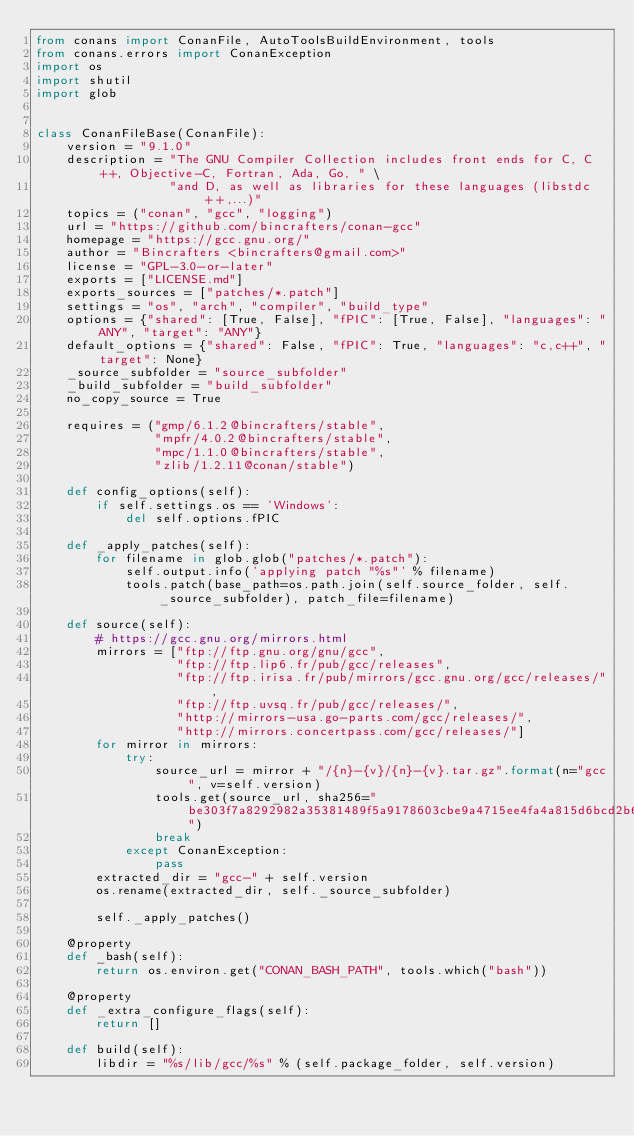<code> <loc_0><loc_0><loc_500><loc_500><_Python_>from conans import ConanFile, AutoToolsBuildEnvironment, tools
from conans.errors import ConanException
import os
import shutil
import glob


class ConanFileBase(ConanFile):
    version = "9.1.0"
    description = "The GNU Compiler Collection includes front ends for C, C++, Objective-C, Fortran, Ada, Go, " \
                  "and D, as well as libraries for these languages (libstdc++,...)"
    topics = ("conan", "gcc", "logging")
    url = "https://github.com/bincrafters/conan-gcc"
    homepage = "https://gcc.gnu.org/"
    author = "Bincrafters <bincrafters@gmail.com>"
    license = "GPL-3.0-or-later"
    exports = ["LICENSE.md"]
    exports_sources = ["patches/*.patch"]
    settings = "os", "arch", "compiler", "build_type"
    options = {"shared": [True, False], "fPIC": [True, False], "languages": "ANY", "target": "ANY"}
    default_options = {"shared": False, "fPIC": True, "languages": "c,c++", "target": None}
    _source_subfolder = "source_subfolder"
    _build_subfolder = "build_subfolder"
    no_copy_source = True

    requires = ("gmp/6.1.2@bincrafters/stable",
                "mpfr/4.0.2@bincrafters/stable",
                "mpc/1.1.0@bincrafters/stable",
                "zlib/1.2.11@conan/stable")

    def config_options(self):
        if self.settings.os == 'Windows':
            del self.options.fPIC

    def _apply_patches(self):
        for filename in glob.glob("patches/*.patch"):
            self.output.info('applying patch "%s"' % filename)
            tools.patch(base_path=os.path.join(self.source_folder, self._source_subfolder), patch_file=filename)

    def source(self):
        # https://gcc.gnu.org/mirrors.html
        mirrors = ["ftp://ftp.gnu.org/gnu/gcc",
                   "ftp://ftp.lip6.fr/pub/gcc/releases",
                   "ftp://ftp.irisa.fr/pub/mirrors/gcc.gnu.org/gcc/releases/",
                   "ftp://ftp.uvsq.fr/pub/gcc/releases/",
                   "http://mirrors-usa.go-parts.com/gcc/releases/",
                   "http://mirrors.concertpass.com/gcc/releases/"]
        for mirror in mirrors:
            try:
                source_url = mirror + "/{n}-{v}/{n}-{v}.tar.gz".format(n="gcc", v=self.version)
                tools.get(source_url, sha256="be303f7a8292982a35381489f5a9178603cbe9a4715ee4fa4a815d6bcd2b658d")
                break
            except ConanException:
                pass
        extracted_dir = "gcc-" + self.version
        os.rename(extracted_dir, self._source_subfolder)

        self._apply_patches()

    @property
    def _bash(self):
        return os.environ.get("CONAN_BASH_PATH", tools.which("bash"))

    @property
    def _extra_configure_flags(self):
        return []

    def build(self):
        libdir = "%s/lib/gcc/%s" % (self.package_folder, self.version)</code> 